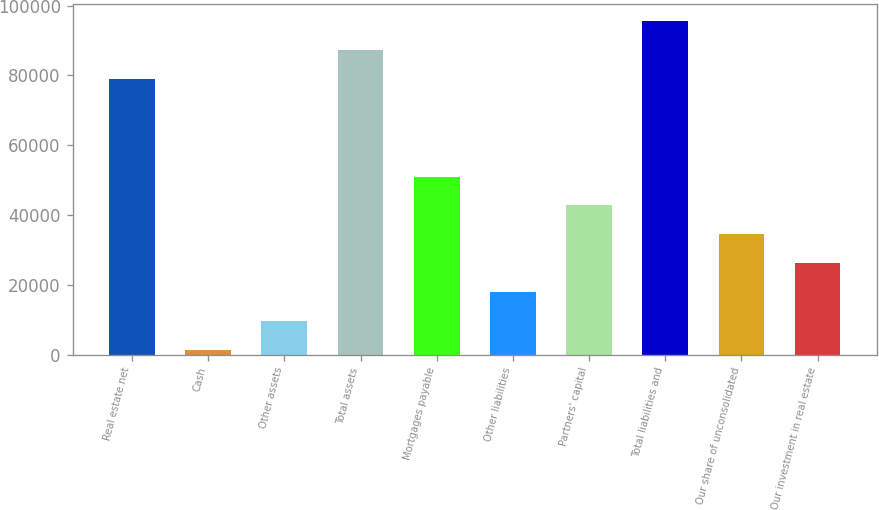Convert chart. <chart><loc_0><loc_0><loc_500><loc_500><bar_chart><fcel>Real estate net<fcel>Cash<fcel>Other assets<fcel>Total assets<fcel>Mortgages payable<fcel>Other liabilities<fcel>Partners' capital<fcel>Total liabilities and<fcel>Our share of unconsolidated<fcel>Our investment in real estate<nl><fcel>79050<fcel>1452<fcel>9716.9<fcel>87314.9<fcel>51041.4<fcel>17981.8<fcel>42776.5<fcel>95579.8<fcel>34511.6<fcel>26246.7<nl></chart> 